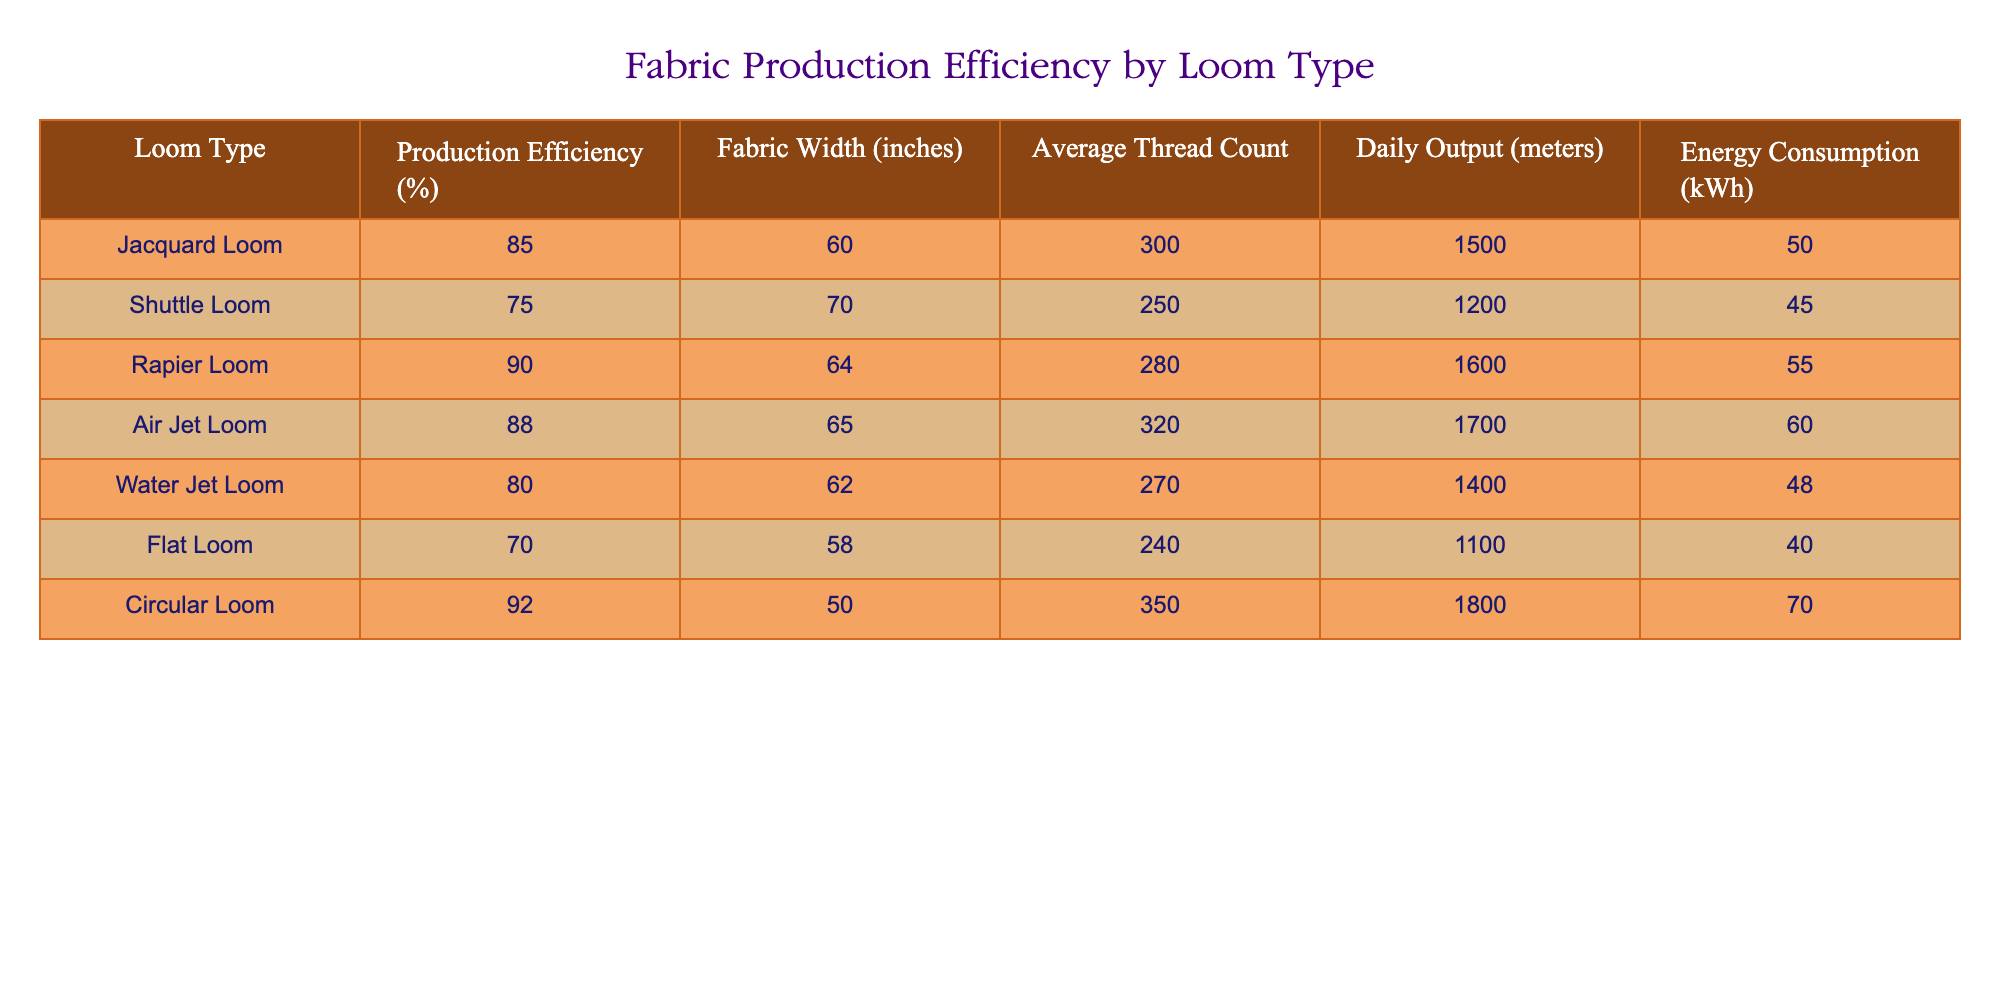What is the production efficiency of the Air Jet Loom? The production efficiency is listed in the column for Production Efficiency. For the Air Jet Loom, the value is 88%.
Answer: 88% Which loom type has the highest daily output? The daily output values can be found in the corresponding column. By comparing all the values, the Circular Loom has the highest output at 1800 meters.
Answer: Circular Loom Is the Shuttle Loom more efficient than the Water Jet Loom? The efficiencies for each loom type can be found in the Production Efficiency column. The Shuttle Loom has 75% and the Water Jet Loom has 80%. Since 75% is less than 80%, the Shuttle Loom is not more efficient.
Answer: No What is the average daily output of looms with production efficiencies greater than 85%? First, identify the looms with efficiencies greater than 85%, which are Jacquard Loom, Rapier Loom, Air Jet Loom, and Circular Loom. Their daily outputs are 1500, 1600, 1700, and 1800 meters respectively. The average can be calculated by summing these values (1500 + 1600 + 1700 + 1800 = 6600) and dividing by the number of looms (4). The average is 6600 / 4 = 1650 meters.
Answer: 1650 meters Does the average thread count increase with production efficiency? To determine this, we need to compare the thread counts of looms in ascending order of efficiency. The average thread count can be calculated for looms grouped by their efficiencies to see if there is a trend. The counts for each efficiency are as follows: 240 (Flat), 250 (Shuttle), 270 (Water Jet), 280 (Rapier), 300 (Jacquard), 320 (Air Jet), 350 (Circular). Observing this, we notice a tendency that might suggest a relationship in some cases, but it doesn't consistently show that higher efficiency correlates directly with higher thread count. Therefore, it is more complex to say definitively without further statistical analysis.
Answer: No What is the difference in energy consumption between the Circular Loom and the Flat Loom? The energy consumption values are in the Energy Consumption column for the Circular Loom (70 kWh) and the Flat Loom (40 kWh). The difference can be found by subtracting the lower value from the higher one: 70 - 40 = 30 kWh.
Answer: 30 kWh 